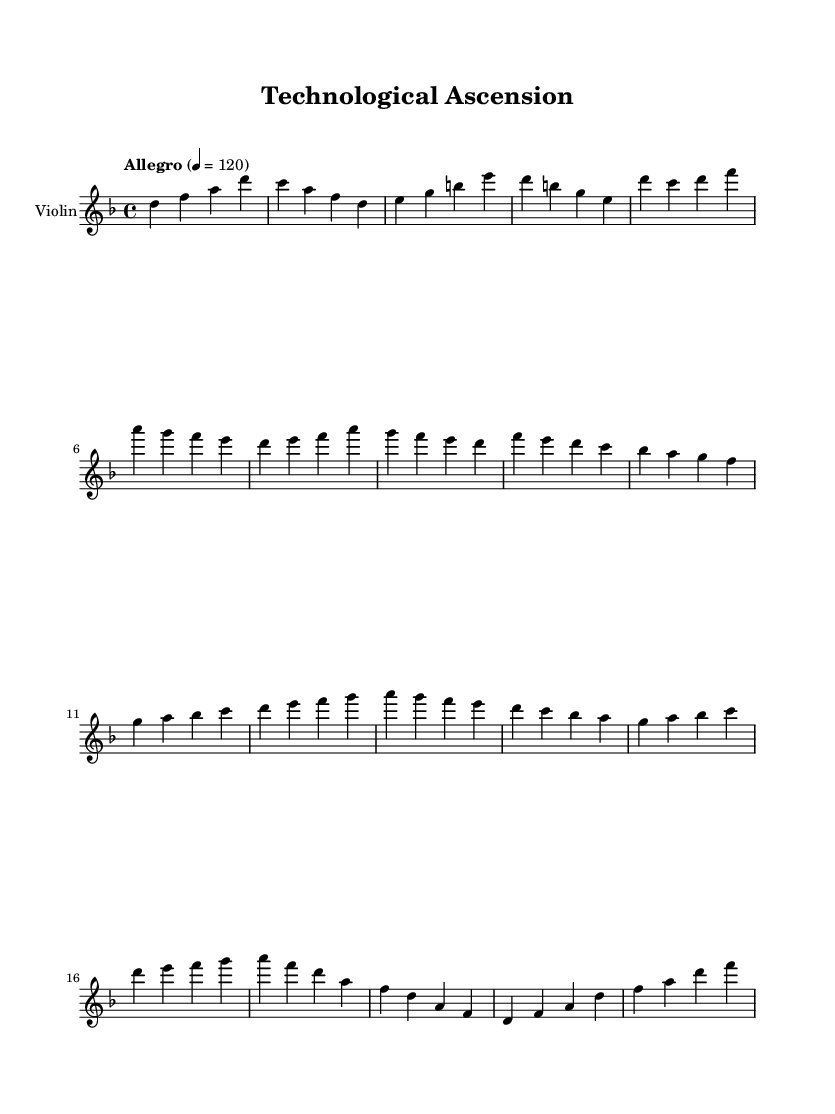What is the key signature of this music? The key signature is D minor, which consists of one flat (B flat).
Answer: D minor What is the time signature of this music? The time signature is 4/4, indicating four beats per measure.
Answer: 4/4 What is the tempo marking in this score? The tempo marking is "Allegro," which indicates a fast and lively tempo.
Answer: Allegro How many distinct themes can be identified in the score? The score presents two distinct themes labeled as Theme A and Theme B, partially represented in the violin part.
Answer: Two What is the climax musical section represented in this piece? The climax section features rising and energetic phrases, indicated by the ascending notes in the sequence.
Answer: Climax Which instrument is specified for this score? The specified instrument for this score is the violin, as noted in the instrument designation.
Answer: Violin How does the piece conclude? The piece concludes with a Coda that returns to earlier themes and provides a resolved ending.
Answer: Coda 